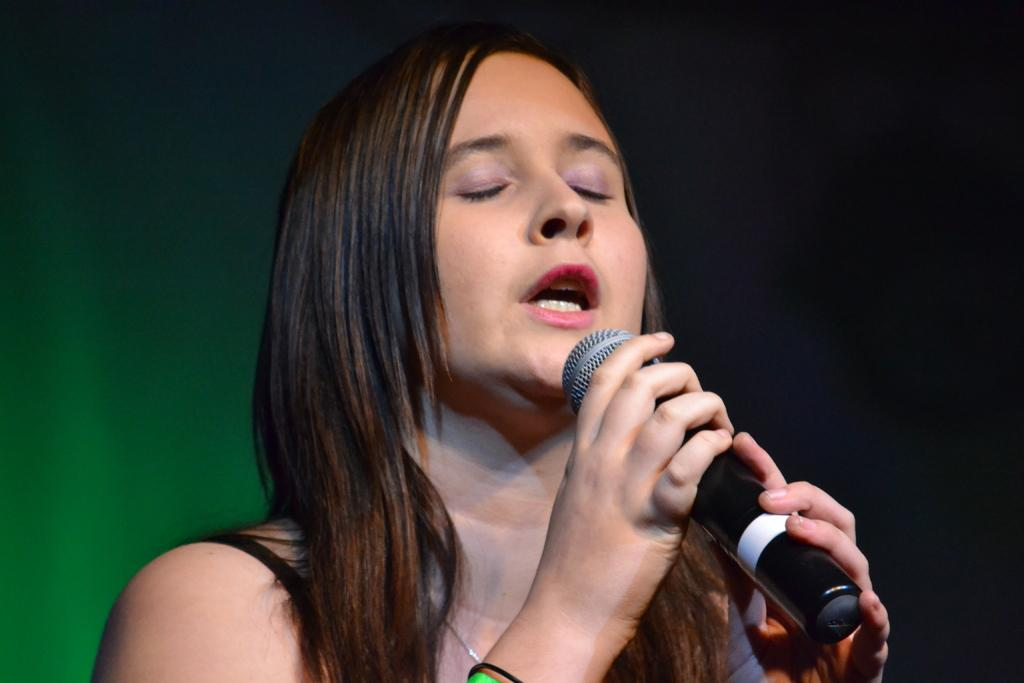What is the main subject of the image? There is a person in the image. What is the person holding in the image? The person is holding a microphone. What time of day is it in the image, and where is the throne located? The provided facts do not mention the time of day or the presence of a throne in the image. 